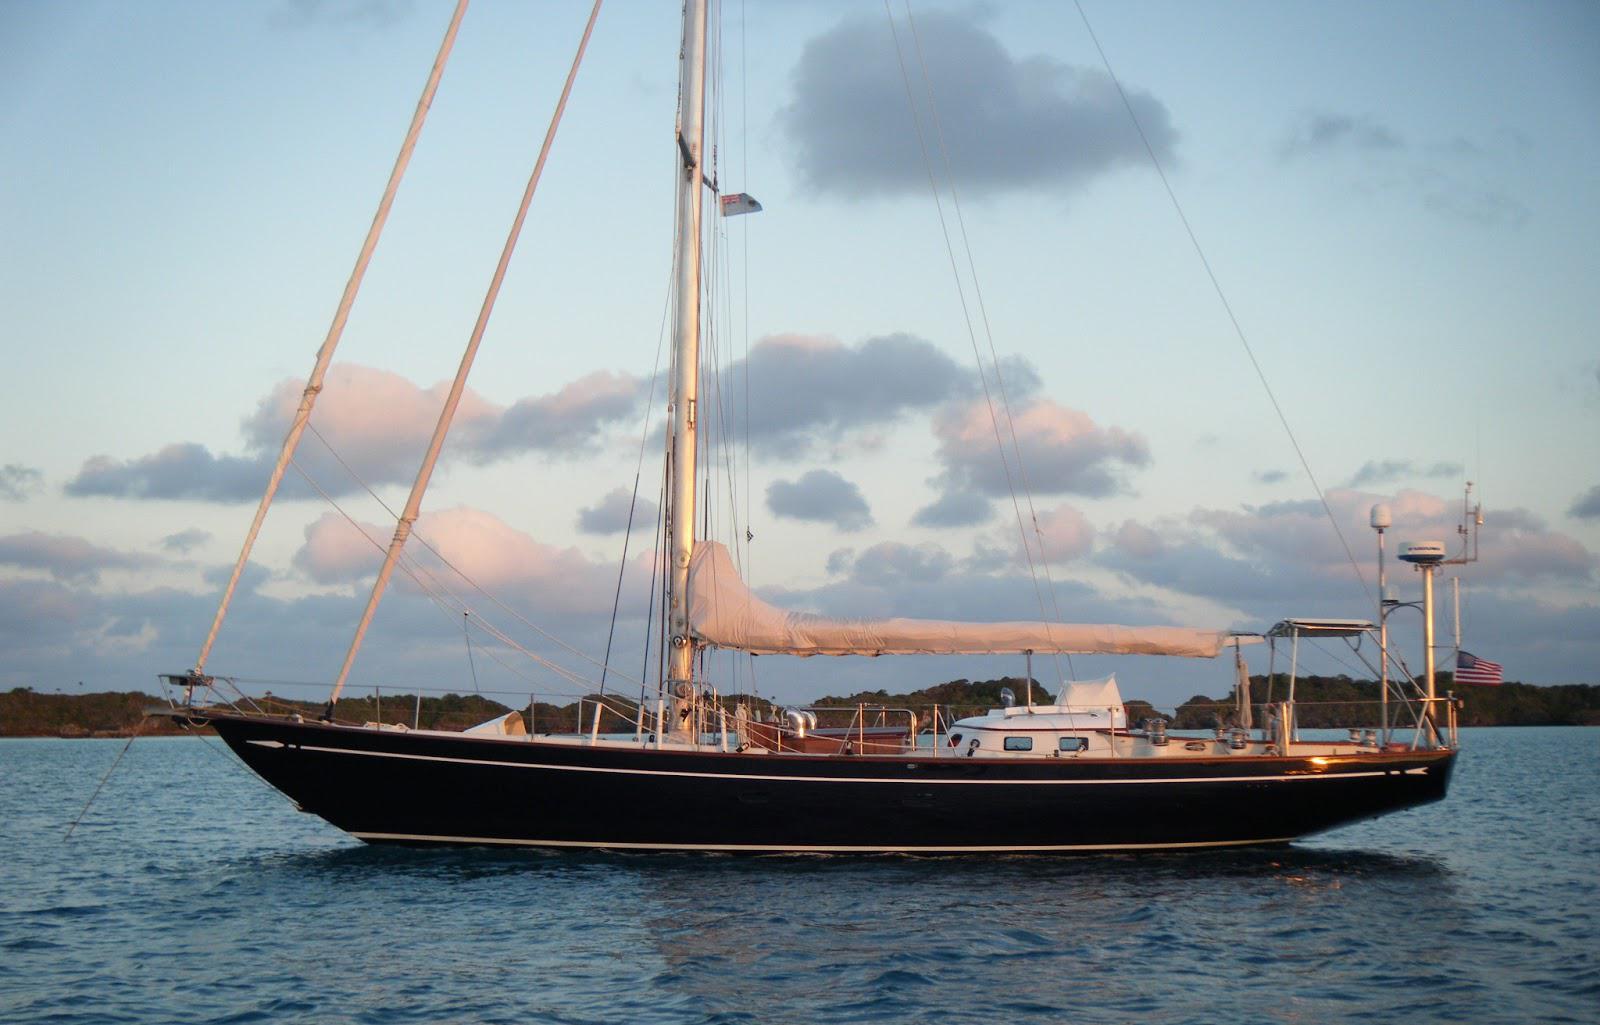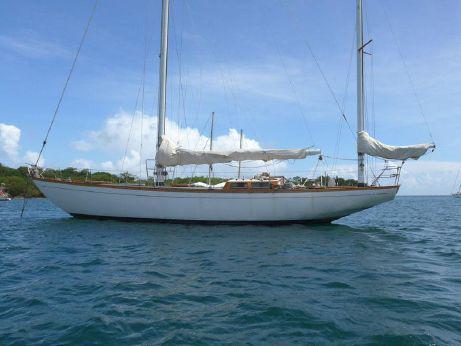The first image is the image on the left, the second image is the image on the right. Evaluate the accuracy of this statement regarding the images: "The left and right image contains the same sailboat facing opposite directions.". Is it true? Answer yes or no. No. 